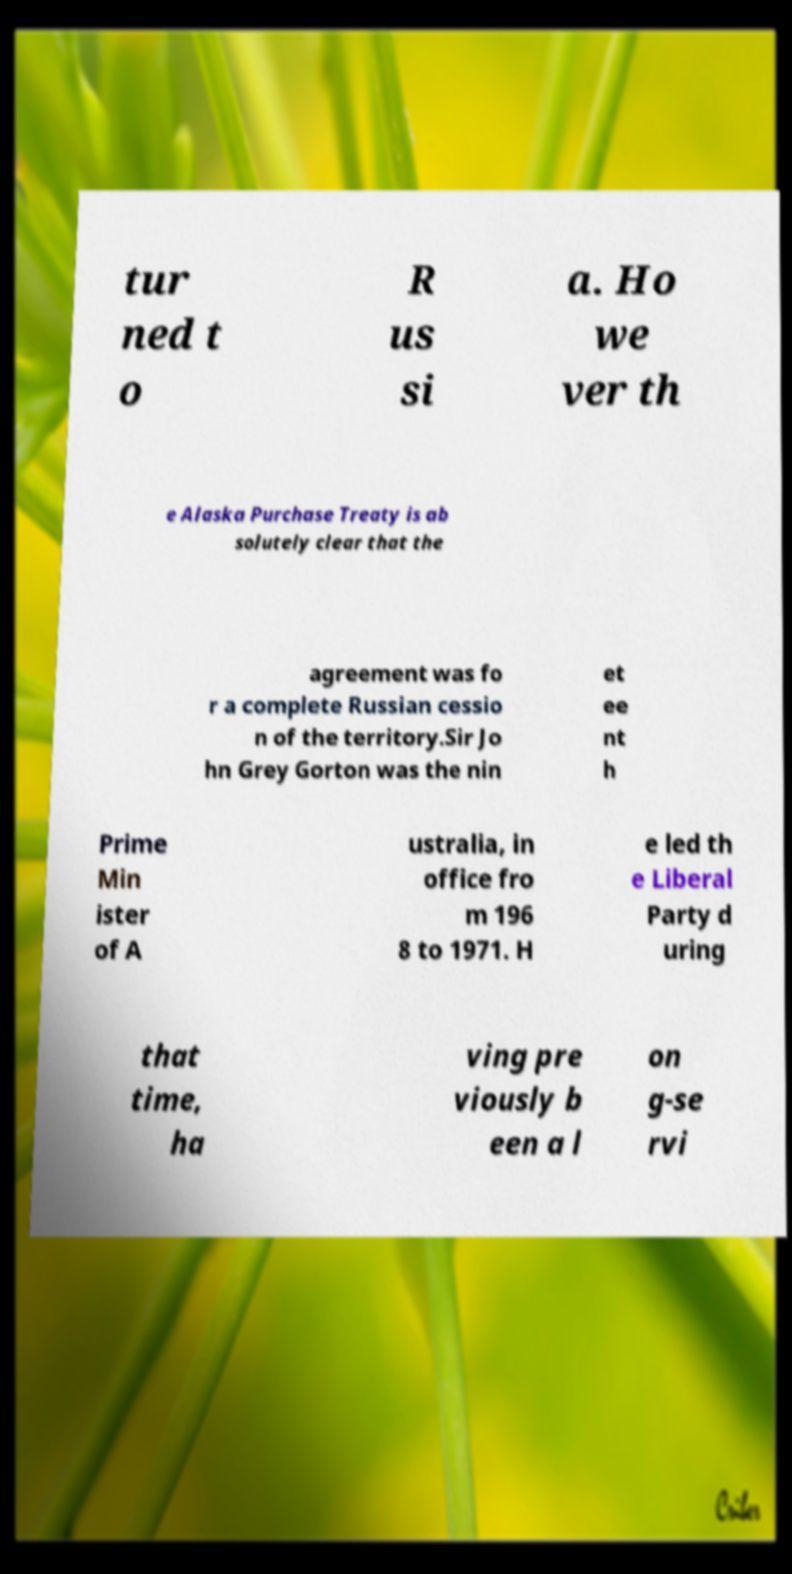There's text embedded in this image that I need extracted. Can you transcribe it verbatim? tur ned t o R us si a. Ho we ver th e Alaska Purchase Treaty is ab solutely clear that the agreement was fo r a complete Russian cessio n of the territory.Sir Jo hn Grey Gorton was the nin et ee nt h Prime Min ister of A ustralia, in office fro m 196 8 to 1971. H e led th e Liberal Party d uring that time, ha ving pre viously b een a l on g-se rvi 